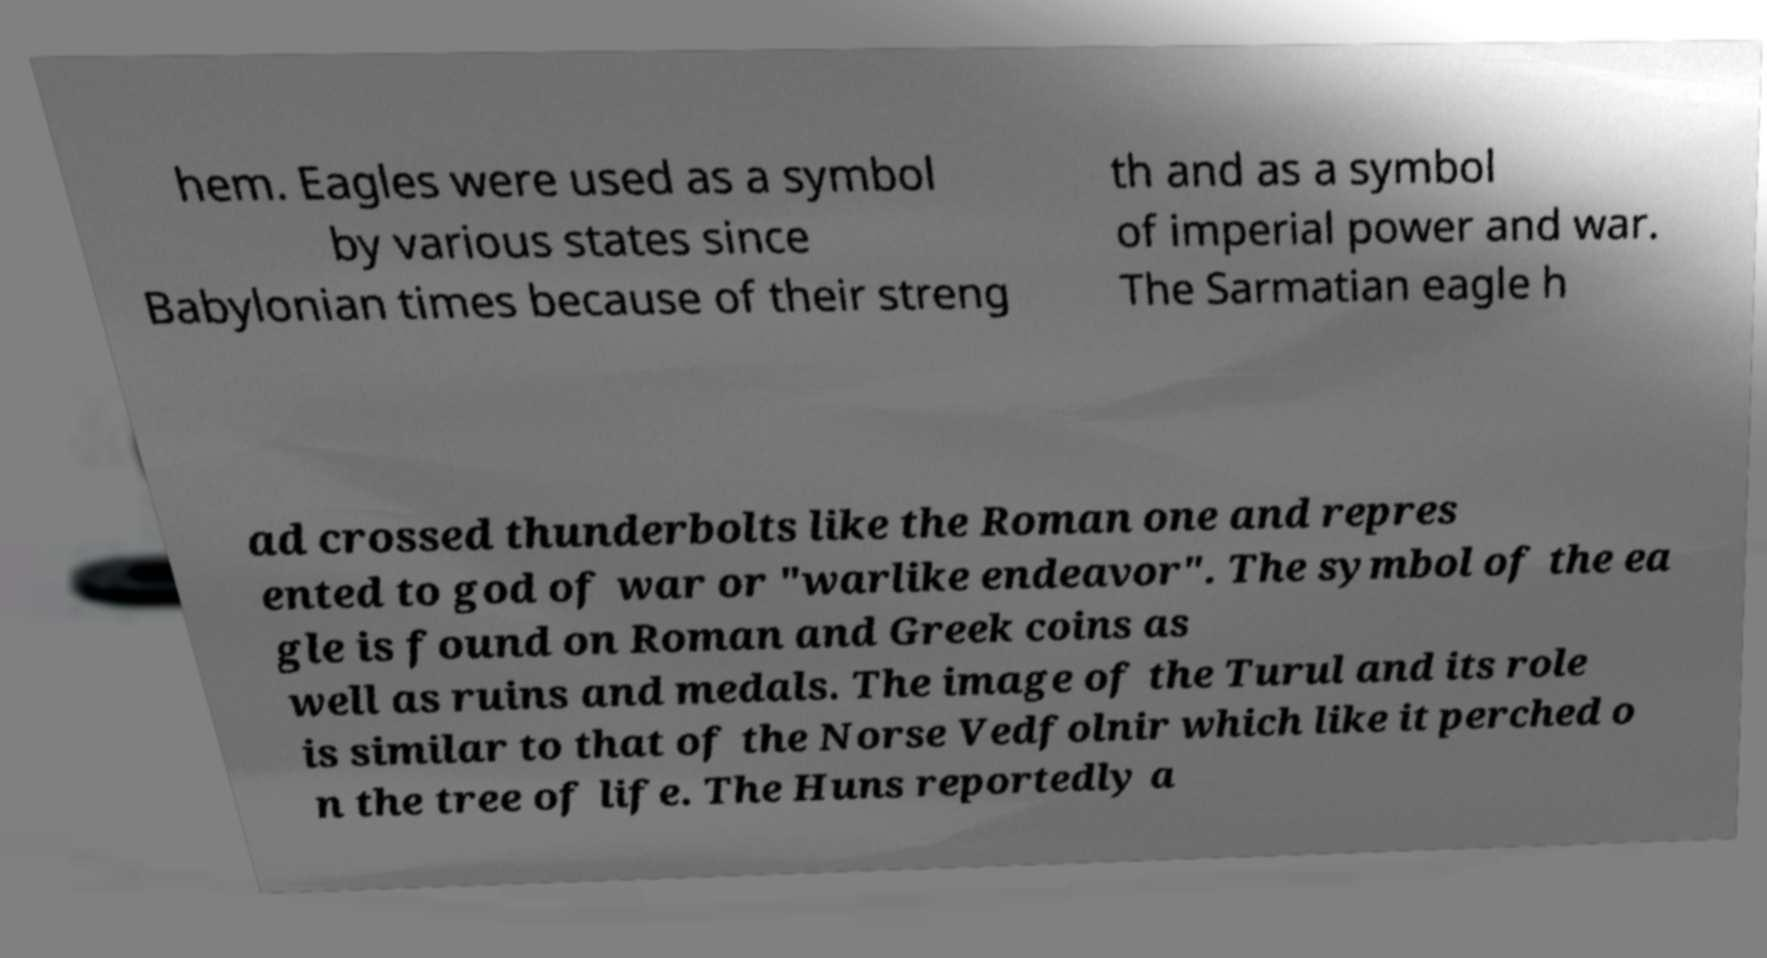Could you assist in decoding the text presented in this image and type it out clearly? hem. Eagles were used as a symbol by various states since Babylonian times because of their streng th and as a symbol of imperial power and war. The Sarmatian eagle h ad crossed thunderbolts like the Roman one and repres ented to god of war or "warlike endeavor". The symbol of the ea gle is found on Roman and Greek coins as well as ruins and medals. The image of the Turul and its role is similar to that of the Norse Vedfolnir which like it perched o n the tree of life. The Huns reportedly a 